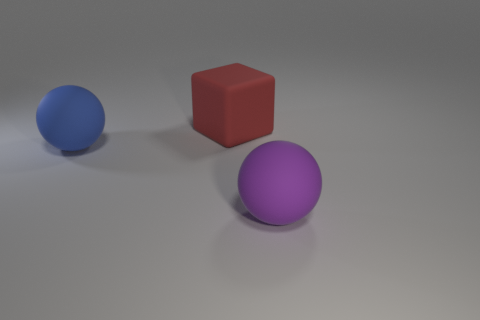What materials could the objects in the image be made of? The objects in the image could be made from various materials commonly used in 3D renderings, including plastic, rubber, or even glass with a matte or frosted finish. The smooth surfaces and the way they reflect light hint at their materiality. 